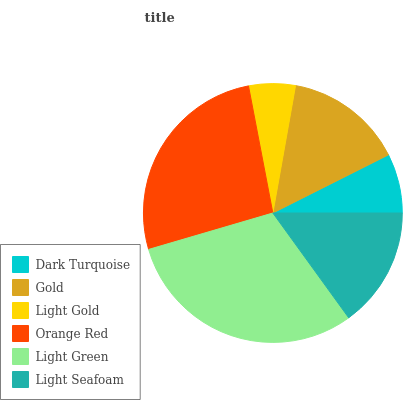Is Light Gold the minimum?
Answer yes or no. Yes. Is Light Green the maximum?
Answer yes or no. Yes. Is Gold the minimum?
Answer yes or no. No. Is Gold the maximum?
Answer yes or no. No. Is Gold greater than Dark Turquoise?
Answer yes or no. Yes. Is Dark Turquoise less than Gold?
Answer yes or no. Yes. Is Dark Turquoise greater than Gold?
Answer yes or no. No. Is Gold less than Dark Turquoise?
Answer yes or no. No. Is Light Seafoam the high median?
Answer yes or no. Yes. Is Gold the low median?
Answer yes or no. Yes. Is Orange Red the high median?
Answer yes or no. No. Is Light Green the low median?
Answer yes or no. No. 